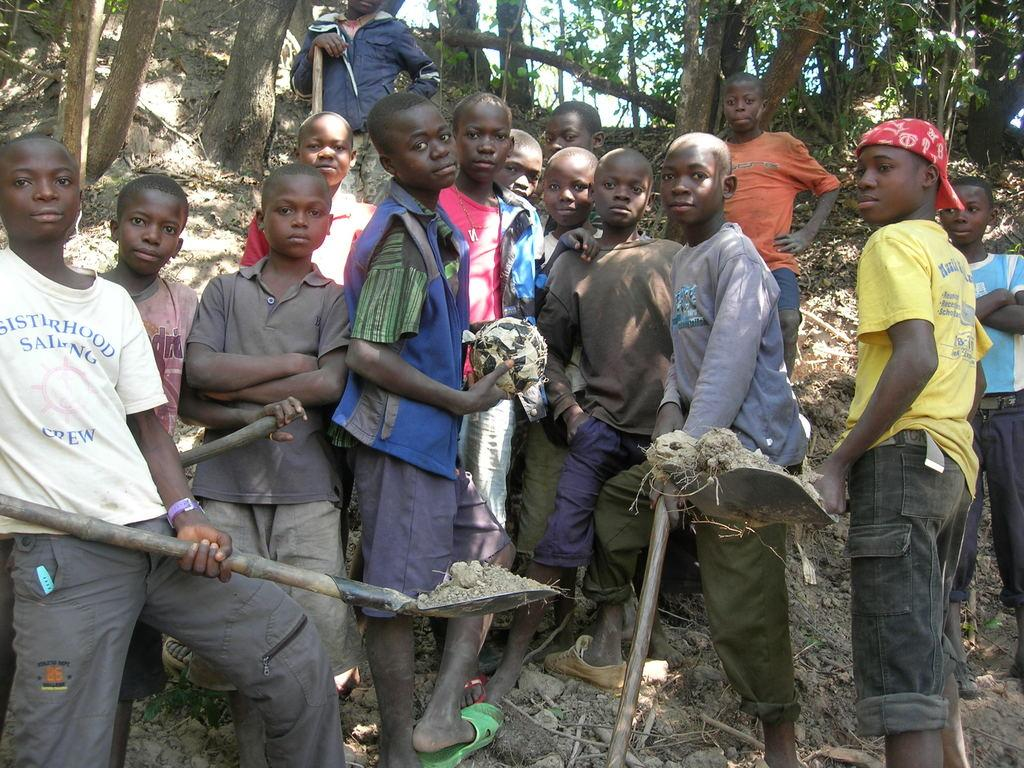What are the children doing in the image? The children are standing on the ground and holding digging tools. What can be seen in the background of the image? There are trees and the sky visible in the background of the image. What type of cloth is being used for reading in the image? There is no cloth or reading activity present in the image. How many additional children are visible in the image, making a total of five? The image only shows the children who are already mentioned, and there is no indication of a fifth child. 